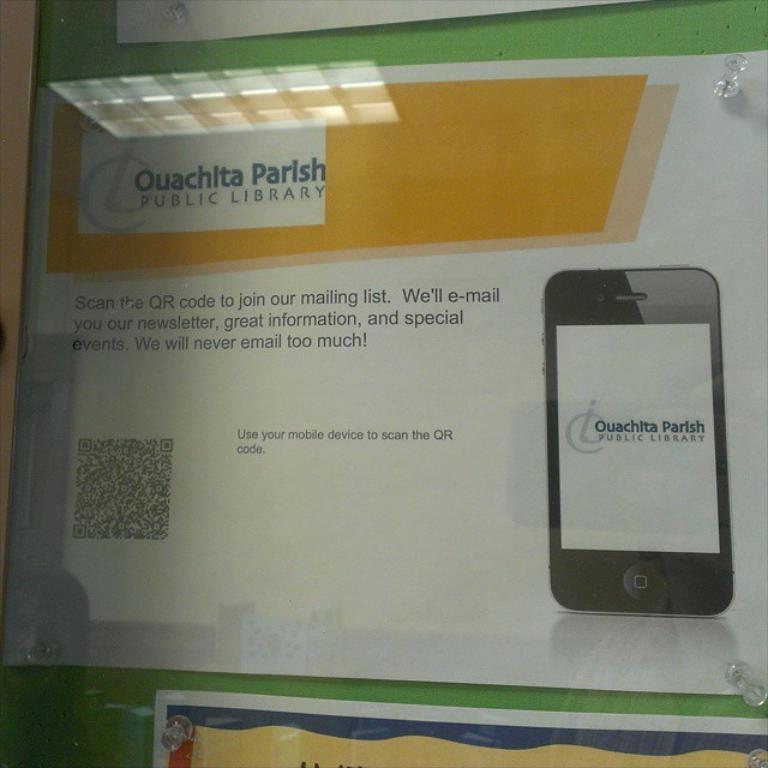<image>
Relay a brief, clear account of the picture shown. A notice from the Ouachita Parish Public Library to scan a QR code on your smartphone to get on their mailing list. 